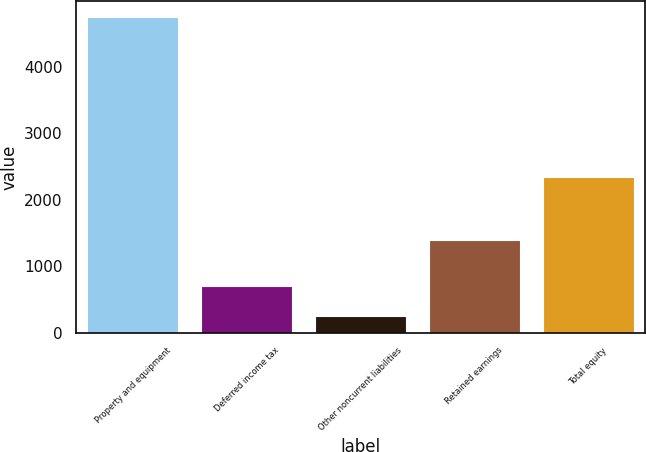Convert chart. <chart><loc_0><loc_0><loc_500><loc_500><bar_chart><fcel>Property and equipment<fcel>Deferred income tax<fcel>Other noncurrent liabilities<fcel>Retained earnings<fcel>Total equity<nl><fcel>4747.2<fcel>697.65<fcel>247.7<fcel>1394.6<fcel>2341.6<nl></chart> 